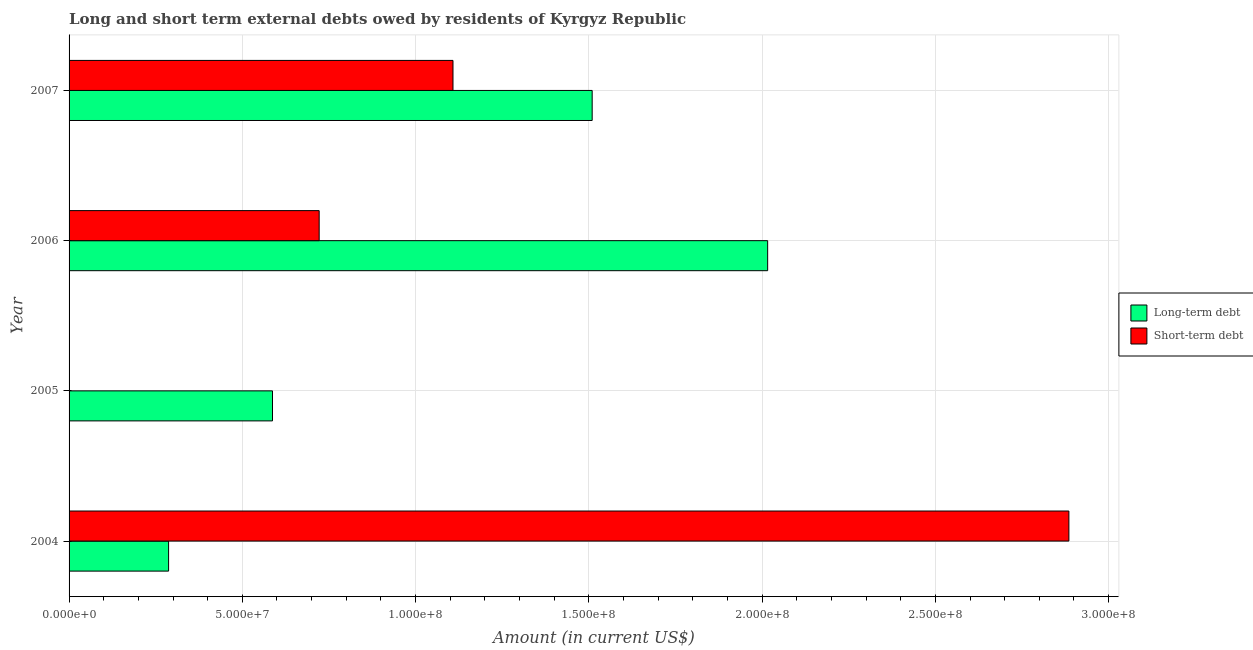Are the number of bars per tick equal to the number of legend labels?
Offer a terse response. No. How many bars are there on the 4th tick from the top?
Provide a short and direct response. 2. How many bars are there on the 3rd tick from the bottom?
Your response must be concise. 2. What is the label of the 4th group of bars from the top?
Offer a very short reply. 2004. What is the short-term debts owed by residents in 2006?
Provide a succinct answer. 7.22e+07. Across all years, what is the maximum short-term debts owed by residents?
Provide a short and direct response. 2.89e+08. Across all years, what is the minimum short-term debts owed by residents?
Your answer should be compact. 0. What is the total long-term debts owed by residents in the graph?
Your response must be concise. 4.40e+08. What is the difference between the short-term debts owed by residents in 2004 and that in 2007?
Ensure brevity in your answer.  1.78e+08. What is the difference between the long-term debts owed by residents in 2005 and the short-term debts owed by residents in 2006?
Offer a very short reply. -1.35e+07. What is the average short-term debts owed by residents per year?
Offer a terse response. 1.18e+08. In the year 2007, what is the difference between the short-term debts owed by residents and long-term debts owed by residents?
Give a very brief answer. -4.02e+07. In how many years, is the long-term debts owed by residents greater than 220000000 US$?
Give a very brief answer. 0. What is the ratio of the short-term debts owed by residents in 2004 to that in 2006?
Provide a short and direct response. 4. Is the long-term debts owed by residents in 2004 less than that in 2006?
Provide a short and direct response. Yes. What is the difference between the highest and the second highest long-term debts owed by residents?
Your answer should be very brief. 5.06e+07. What is the difference between the highest and the lowest long-term debts owed by residents?
Your response must be concise. 1.73e+08. How many bars are there?
Provide a succinct answer. 7. What is the difference between two consecutive major ticks on the X-axis?
Provide a short and direct response. 5.00e+07. Are the values on the major ticks of X-axis written in scientific E-notation?
Provide a succinct answer. Yes. Does the graph contain any zero values?
Ensure brevity in your answer.  Yes. Does the graph contain grids?
Your answer should be very brief. Yes. How are the legend labels stacked?
Offer a very short reply. Vertical. What is the title of the graph?
Give a very brief answer. Long and short term external debts owed by residents of Kyrgyz Republic. Does "Private creditors" appear as one of the legend labels in the graph?
Make the answer very short. No. What is the label or title of the X-axis?
Give a very brief answer. Amount (in current US$). What is the label or title of the Y-axis?
Keep it short and to the point. Year. What is the Amount (in current US$) of Long-term debt in 2004?
Make the answer very short. 2.87e+07. What is the Amount (in current US$) of Short-term debt in 2004?
Your answer should be very brief. 2.89e+08. What is the Amount (in current US$) of Long-term debt in 2005?
Offer a very short reply. 5.87e+07. What is the Amount (in current US$) of Long-term debt in 2006?
Your response must be concise. 2.02e+08. What is the Amount (in current US$) in Short-term debt in 2006?
Give a very brief answer. 7.22e+07. What is the Amount (in current US$) in Long-term debt in 2007?
Make the answer very short. 1.51e+08. What is the Amount (in current US$) of Short-term debt in 2007?
Provide a short and direct response. 1.11e+08. Across all years, what is the maximum Amount (in current US$) of Long-term debt?
Give a very brief answer. 2.02e+08. Across all years, what is the maximum Amount (in current US$) in Short-term debt?
Provide a short and direct response. 2.89e+08. Across all years, what is the minimum Amount (in current US$) in Long-term debt?
Your answer should be very brief. 2.87e+07. What is the total Amount (in current US$) of Long-term debt in the graph?
Offer a very short reply. 4.40e+08. What is the total Amount (in current US$) in Short-term debt in the graph?
Give a very brief answer. 4.72e+08. What is the difference between the Amount (in current US$) of Long-term debt in 2004 and that in 2005?
Keep it short and to the point. -3.00e+07. What is the difference between the Amount (in current US$) in Long-term debt in 2004 and that in 2006?
Offer a very short reply. -1.73e+08. What is the difference between the Amount (in current US$) of Short-term debt in 2004 and that in 2006?
Give a very brief answer. 2.16e+08. What is the difference between the Amount (in current US$) of Long-term debt in 2004 and that in 2007?
Give a very brief answer. -1.22e+08. What is the difference between the Amount (in current US$) in Short-term debt in 2004 and that in 2007?
Offer a very short reply. 1.78e+08. What is the difference between the Amount (in current US$) of Long-term debt in 2005 and that in 2006?
Ensure brevity in your answer.  -1.43e+08. What is the difference between the Amount (in current US$) in Long-term debt in 2005 and that in 2007?
Provide a short and direct response. -9.23e+07. What is the difference between the Amount (in current US$) in Long-term debt in 2006 and that in 2007?
Provide a short and direct response. 5.06e+07. What is the difference between the Amount (in current US$) in Short-term debt in 2006 and that in 2007?
Give a very brief answer. -3.86e+07. What is the difference between the Amount (in current US$) in Long-term debt in 2004 and the Amount (in current US$) in Short-term debt in 2006?
Provide a short and direct response. -4.35e+07. What is the difference between the Amount (in current US$) of Long-term debt in 2004 and the Amount (in current US$) of Short-term debt in 2007?
Make the answer very short. -8.21e+07. What is the difference between the Amount (in current US$) of Long-term debt in 2005 and the Amount (in current US$) of Short-term debt in 2006?
Provide a succinct answer. -1.35e+07. What is the difference between the Amount (in current US$) of Long-term debt in 2005 and the Amount (in current US$) of Short-term debt in 2007?
Offer a very short reply. -5.21e+07. What is the difference between the Amount (in current US$) of Long-term debt in 2006 and the Amount (in current US$) of Short-term debt in 2007?
Your answer should be very brief. 9.08e+07. What is the average Amount (in current US$) in Long-term debt per year?
Offer a very short reply. 1.10e+08. What is the average Amount (in current US$) in Short-term debt per year?
Make the answer very short. 1.18e+08. In the year 2004, what is the difference between the Amount (in current US$) of Long-term debt and Amount (in current US$) of Short-term debt?
Make the answer very short. -2.60e+08. In the year 2006, what is the difference between the Amount (in current US$) of Long-term debt and Amount (in current US$) of Short-term debt?
Offer a terse response. 1.29e+08. In the year 2007, what is the difference between the Amount (in current US$) in Long-term debt and Amount (in current US$) in Short-term debt?
Offer a very short reply. 4.02e+07. What is the ratio of the Amount (in current US$) in Long-term debt in 2004 to that in 2005?
Give a very brief answer. 0.49. What is the ratio of the Amount (in current US$) in Long-term debt in 2004 to that in 2006?
Your response must be concise. 0.14. What is the ratio of the Amount (in current US$) of Short-term debt in 2004 to that in 2006?
Offer a terse response. 4. What is the ratio of the Amount (in current US$) of Long-term debt in 2004 to that in 2007?
Provide a short and direct response. 0.19. What is the ratio of the Amount (in current US$) in Short-term debt in 2004 to that in 2007?
Your answer should be very brief. 2.6. What is the ratio of the Amount (in current US$) in Long-term debt in 2005 to that in 2006?
Provide a short and direct response. 0.29. What is the ratio of the Amount (in current US$) of Long-term debt in 2005 to that in 2007?
Provide a succinct answer. 0.39. What is the ratio of the Amount (in current US$) in Long-term debt in 2006 to that in 2007?
Keep it short and to the point. 1.34. What is the ratio of the Amount (in current US$) in Short-term debt in 2006 to that in 2007?
Give a very brief answer. 0.65. What is the difference between the highest and the second highest Amount (in current US$) in Long-term debt?
Give a very brief answer. 5.06e+07. What is the difference between the highest and the second highest Amount (in current US$) of Short-term debt?
Offer a very short reply. 1.78e+08. What is the difference between the highest and the lowest Amount (in current US$) of Long-term debt?
Make the answer very short. 1.73e+08. What is the difference between the highest and the lowest Amount (in current US$) of Short-term debt?
Your answer should be very brief. 2.89e+08. 